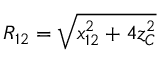<formula> <loc_0><loc_0><loc_500><loc_500>R _ { 1 2 } = \sqrt { x _ { 1 2 } ^ { 2 } + 4 z _ { C } ^ { 2 } }</formula> 